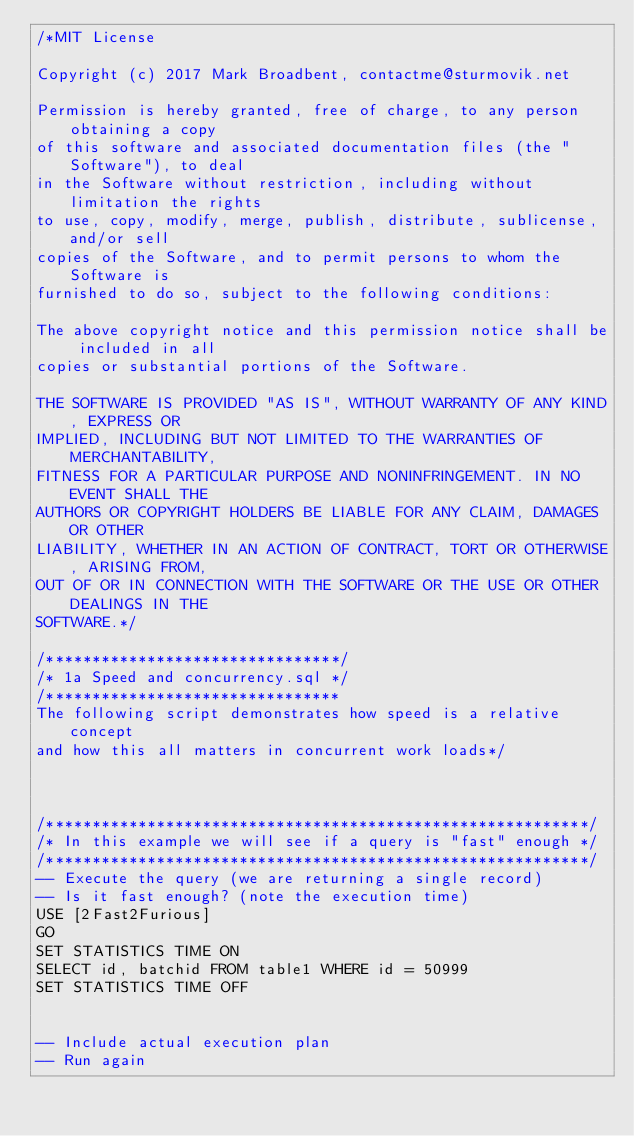Convert code to text. <code><loc_0><loc_0><loc_500><loc_500><_SQL_>/*MIT License

Copyright (c) 2017 Mark Broadbent, contactme@sturmovik.net

Permission is hereby granted, free of charge, to any person obtaining a copy
of this software and associated documentation files (the "Software"), to deal
in the Software without restriction, including without limitation the rights
to use, copy, modify, merge, publish, distribute, sublicense, and/or sell
copies of the Software, and to permit persons to whom the Software is
furnished to do so, subject to the following conditions:

The above copyright notice and this permission notice shall be included in all
copies or substantial portions of the Software.

THE SOFTWARE IS PROVIDED "AS IS", WITHOUT WARRANTY OF ANY KIND, EXPRESS OR
IMPLIED, INCLUDING BUT NOT LIMITED TO THE WARRANTIES OF MERCHANTABILITY,
FITNESS FOR A PARTICULAR PURPOSE AND NONINFRINGEMENT. IN NO EVENT SHALL THE
AUTHORS OR COPYRIGHT HOLDERS BE LIABLE FOR ANY CLAIM, DAMAGES OR OTHER
LIABILITY, WHETHER IN AN ACTION OF CONTRACT, TORT OR OTHERWISE, ARISING FROM,
OUT OF OR IN CONNECTION WITH THE SOFTWARE OR THE USE OR OTHER DEALINGS IN THE
SOFTWARE.*/

/********************************/
/* 1a Speed and concurrency.sql */
/********************************
The following script demonstrates how speed is a relative concept
and how this all matters in concurrent work loads*/



/***********************************************************/
/* In this example we will see if a query is "fast" enough */
/***********************************************************/
-- Execute the query (we are returning a single record)
-- Is it fast enough? (note the execution time)
USE [2Fast2Furious]
GO
SET STATISTICS TIME ON
SELECT id, batchid FROM table1 WHERE id = 50999
SET STATISTICS TIME OFF


-- Include actual execution plan
-- Run again</code> 